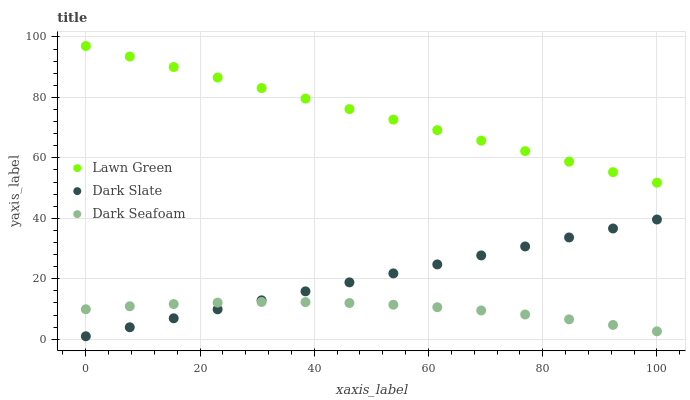Does Dark Seafoam have the minimum area under the curve?
Answer yes or no. Yes. Does Lawn Green have the maximum area under the curve?
Answer yes or no. Yes. Does Dark Slate have the minimum area under the curve?
Answer yes or no. No. Does Dark Slate have the maximum area under the curve?
Answer yes or no. No. Is Dark Slate the smoothest?
Answer yes or no. Yes. Is Dark Seafoam the roughest?
Answer yes or no. Yes. Is Dark Seafoam the smoothest?
Answer yes or no. No. Is Dark Slate the roughest?
Answer yes or no. No. Does Dark Slate have the lowest value?
Answer yes or no. Yes. Does Dark Seafoam have the lowest value?
Answer yes or no. No. Does Lawn Green have the highest value?
Answer yes or no. Yes. Does Dark Slate have the highest value?
Answer yes or no. No. Is Dark Seafoam less than Lawn Green?
Answer yes or no. Yes. Is Lawn Green greater than Dark Slate?
Answer yes or no. Yes. Does Dark Slate intersect Dark Seafoam?
Answer yes or no. Yes. Is Dark Slate less than Dark Seafoam?
Answer yes or no. No. Is Dark Slate greater than Dark Seafoam?
Answer yes or no. No. Does Dark Seafoam intersect Lawn Green?
Answer yes or no. No. 